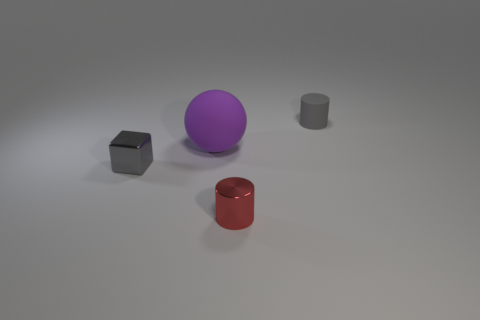Subtract all red cylinders. How many cylinders are left? 1 Add 4 large red rubber cubes. How many objects exist? 8 Subtract all spheres. How many objects are left? 3 Subtract all large balls. Subtract all large matte objects. How many objects are left? 2 Add 3 tiny gray cylinders. How many tiny gray cylinders are left? 4 Add 1 large purple things. How many large purple things exist? 2 Subtract 0 purple cubes. How many objects are left? 4 Subtract all cyan cubes. Subtract all green balls. How many cubes are left? 1 